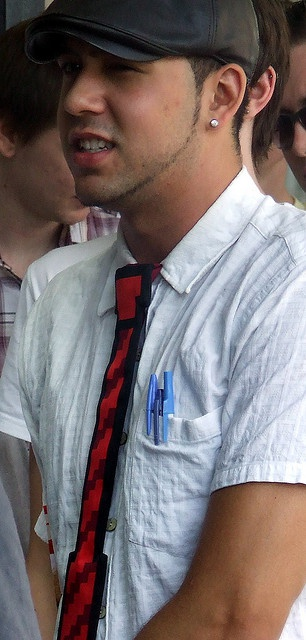Describe the objects in this image and their specific colors. I can see people in black, darkgray, lightgray, and maroon tones, people in black, maroon, and gray tones, tie in black, maroon, and gray tones, people in black, tan, maroon, and brown tones, and people in black and brown tones in this image. 